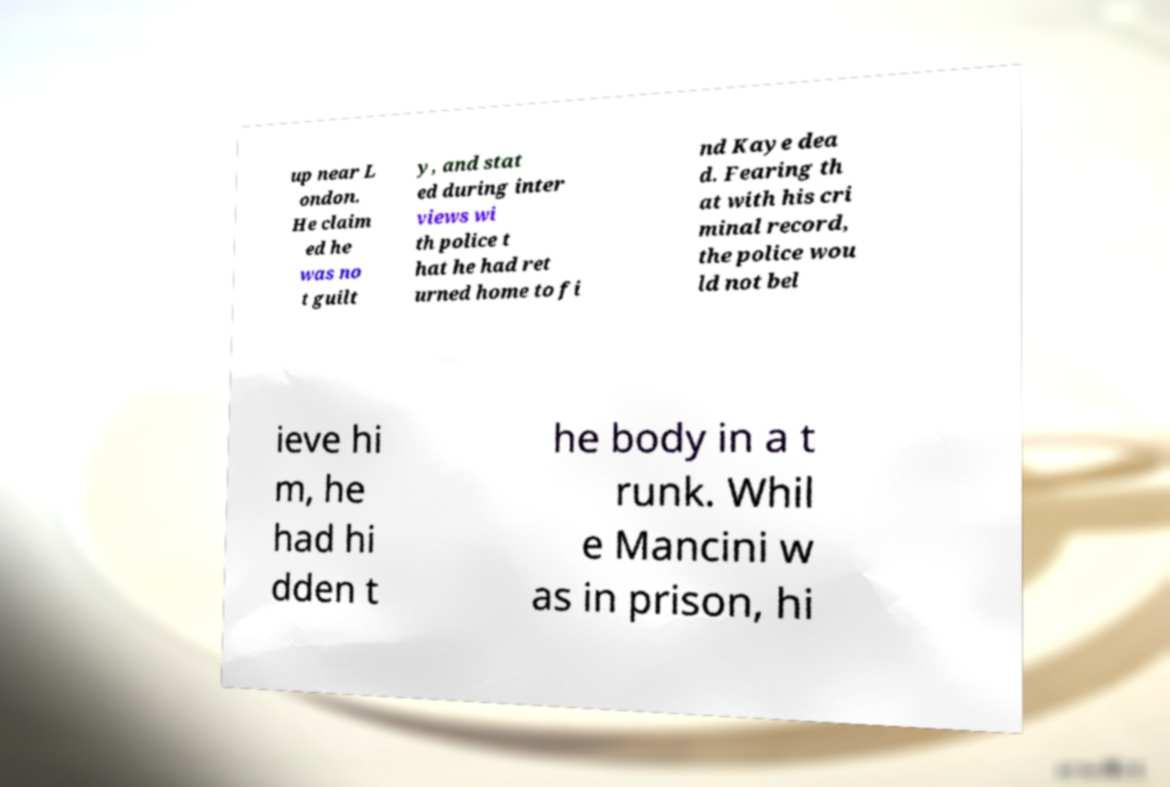There's text embedded in this image that I need extracted. Can you transcribe it verbatim? up near L ondon. He claim ed he was no t guilt y, and stat ed during inter views wi th police t hat he had ret urned home to fi nd Kaye dea d. Fearing th at with his cri minal record, the police wou ld not bel ieve hi m, he had hi dden t he body in a t runk. Whil e Mancini w as in prison, hi 